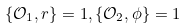<formula> <loc_0><loc_0><loc_500><loc_500>\{ \mathcal { O } _ { 1 } , r \} = 1 , \{ \mathcal { O } _ { 2 } , \phi \} = 1</formula> 